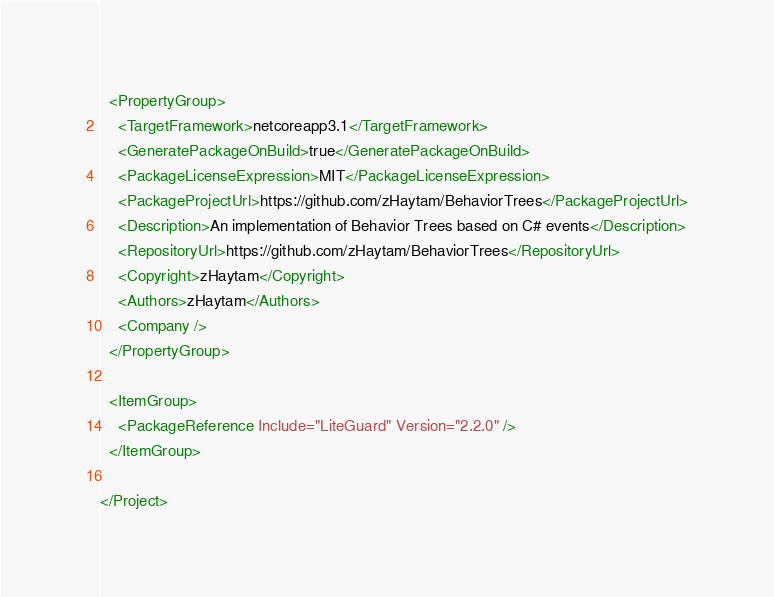<code> <loc_0><loc_0><loc_500><loc_500><_XML_>  <PropertyGroup>
    <TargetFramework>netcoreapp3.1</TargetFramework>
    <GeneratePackageOnBuild>true</GeneratePackageOnBuild>
    <PackageLicenseExpression>MIT</PackageLicenseExpression>
    <PackageProjectUrl>https://github.com/zHaytam/BehaviorTrees</PackageProjectUrl>
    <Description>An implementation of Behavior Trees based on C# events</Description>
    <RepositoryUrl>https://github.com/zHaytam/BehaviorTrees</RepositoryUrl>
    <Copyright>zHaytam</Copyright>
    <Authors>zHaytam</Authors>
    <Company />
  </PropertyGroup>

  <ItemGroup>
    <PackageReference Include="LiteGuard" Version="2.2.0" />
  </ItemGroup>

</Project>
</code> 